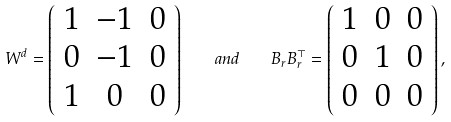Convert formula to latex. <formula><loc_0><loc_0><loc_500><loc_500>W ^ { d } = \left ( \begin{array} { c c c } 1 & - 1 & 0 \\ 0 & - 1 & 0 \\ 1 & 0 & 0 \end{array} \right ) \quad a n d \quad B _ { r } B _ { r } ^ { \top } = \left ( \begin{array} { c c c } 1 & 0 & 0 \\ 0 & 1 & 0 \\ 0 & 0 & 0 \end{array} \right ) ,</formula> 